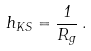<formula> <loc_0><loc_0><loc_500><loc_500>h _ { K S } = \frac { 1 } { R _ { g } } \, .</formula> 